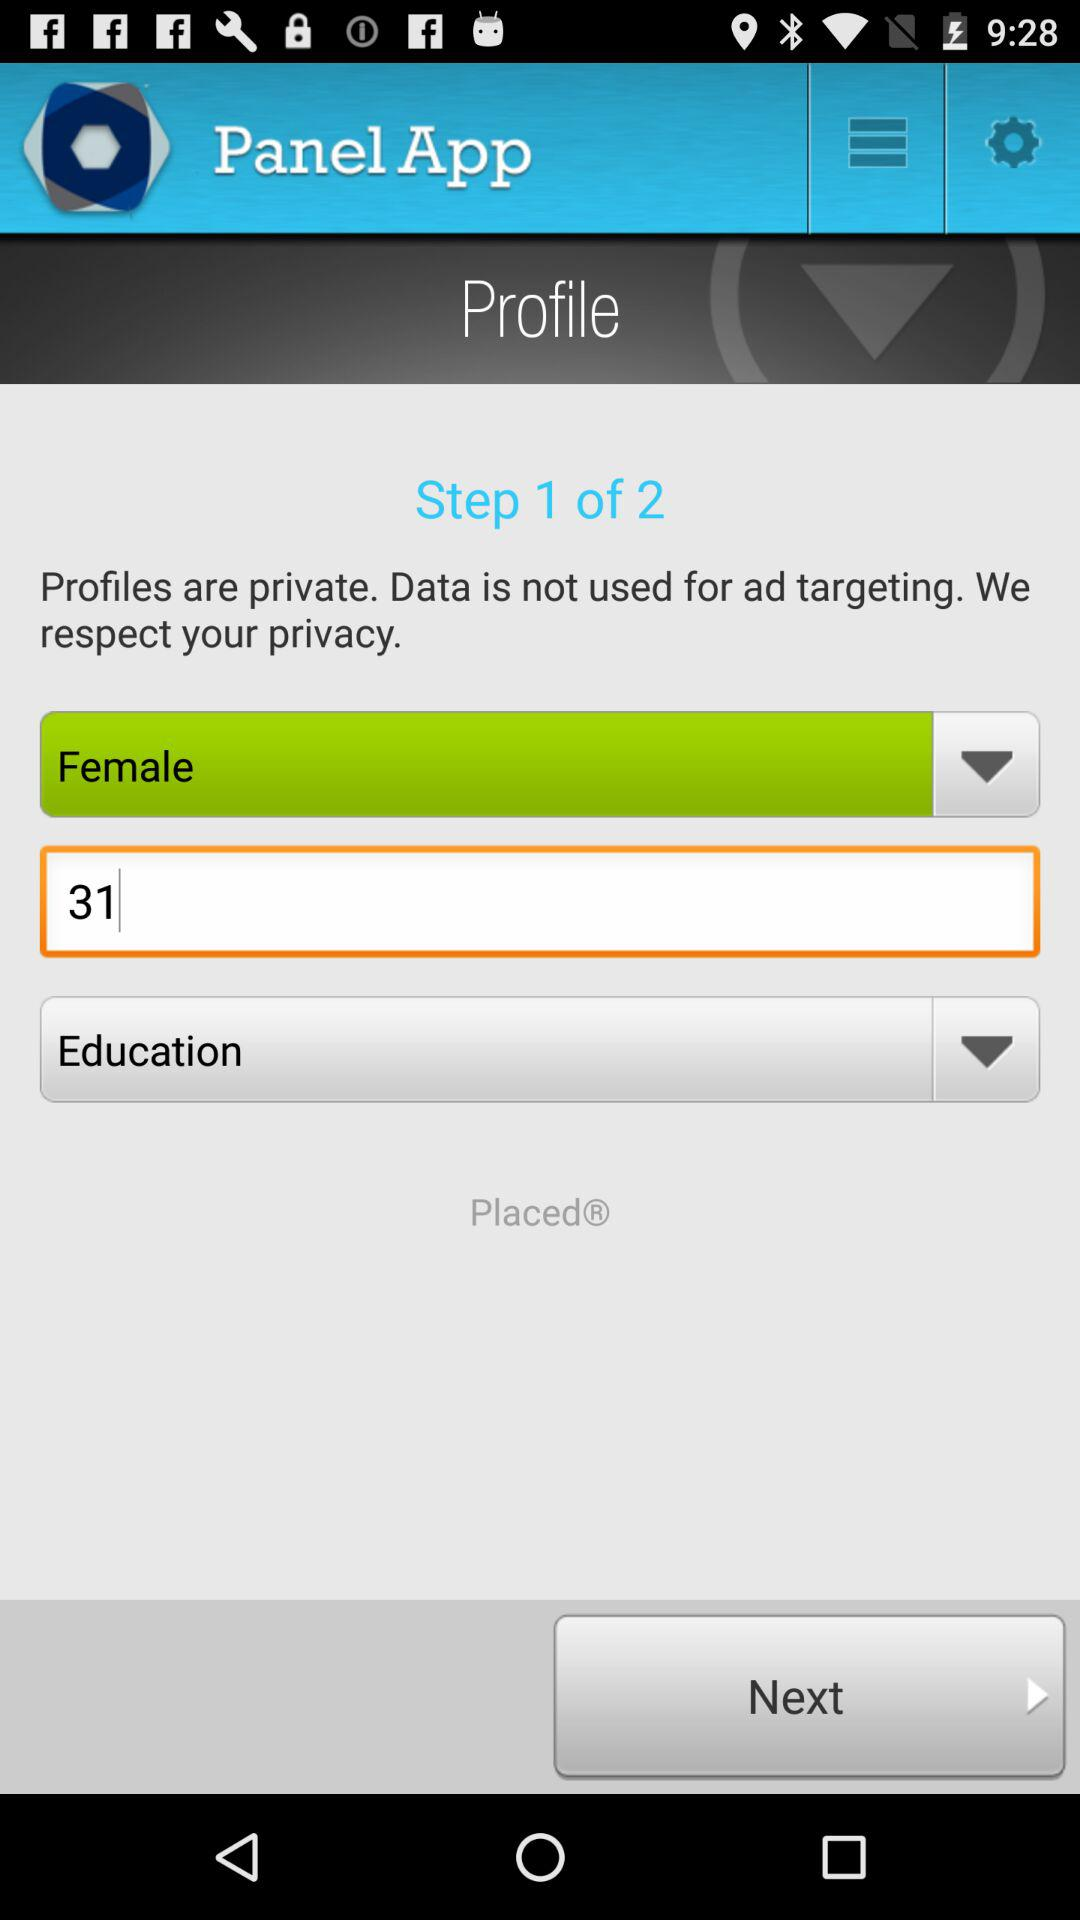On which step currently we are? You are on step 1 currently. 